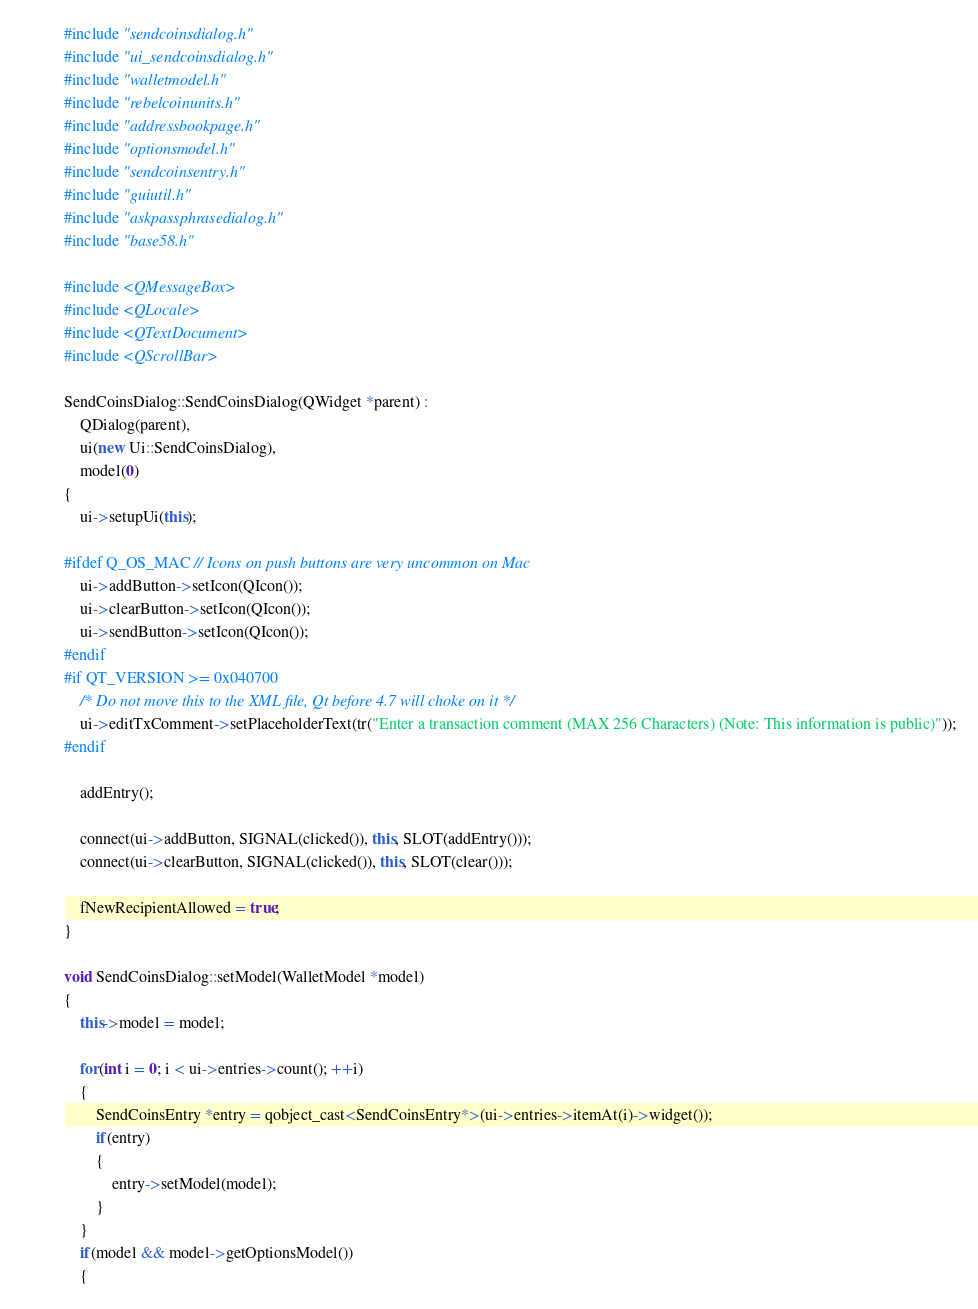<code> <loc_0><loc_0><loc_500><loc_500><_C++_>#include "sendcoinsdialog.h"
#include "ui_sendcoinsdialog.h"
#include "walletmodel.h"
#include "rebelcoinunits.h"
#include "addressbookpage.h"
#include "optionsmodel.h"
#include "sendcoinsentry.h"
#include "guiutil.h"
#include "askpassphrasedialog.h"
#include "base58.h"

#include <QMessageBox>
#include <QLocale>
#include <QTextDocument>
#include <QScrollBar>

SendCoinsDialog::SendCoinsDialog(QWidget *parent) :
    QDialog(parent),
    ui(new Ui::SendCoinsDialog),
    model(0)
{
    ui->setupUi(this);

#ifdef Q_OS_MAC // Icons on push buttons are very uncommon on Mac
    ui->addButton->setIcon(QIcon());
    ui->clearButton->setIcon(QIcon());
    ui->sendButton->setIcon(QIcon());
#endif
#if QT_VERSION >= 0x040700
    /* Do not move this to the XML file, Qt before 4.7 will choke on it */
    ui->editTxComment->setPlaceholderText(tr("Enter a transaction comment (MAX 256 Characters) (Note: This information is public)"));
#endif

    addEntry();

    connect(ui->addButton, SIGNAL(clicked()), this, SLOT(addEntry()));
    connect(ui->clearButton, SIGNAL(clicked()), this, SLOT(clear()));

    fNewRecipientAllowed = true;
}

void SendCoinsDialog::setModel(WalletModel *model)
{
    this->model = model;

    for(int i = 0; i < ui->entries->count(); ++i)
    {
        SendCoinsEntry *entry = qobject_cast<SendCoinsEntry*>(ui->entries->itemAt(i)->widget());
        if(entry)
        {
            entry->setModel(model);
        }
    }
    if(model && model->getOptionsModel())
    {</code> 